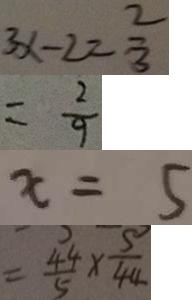Convert formula to latex. <formula><loc_0><loc_0><loc_500><loc_500>3 x - 2 = \frac { 2 } { 3 } 
 = \frac { 2 } { 9 } 
 x = 5 
 = \frac { 4 4 } { 5 } \times \frac { 5 } { 4 4 }</formula> 